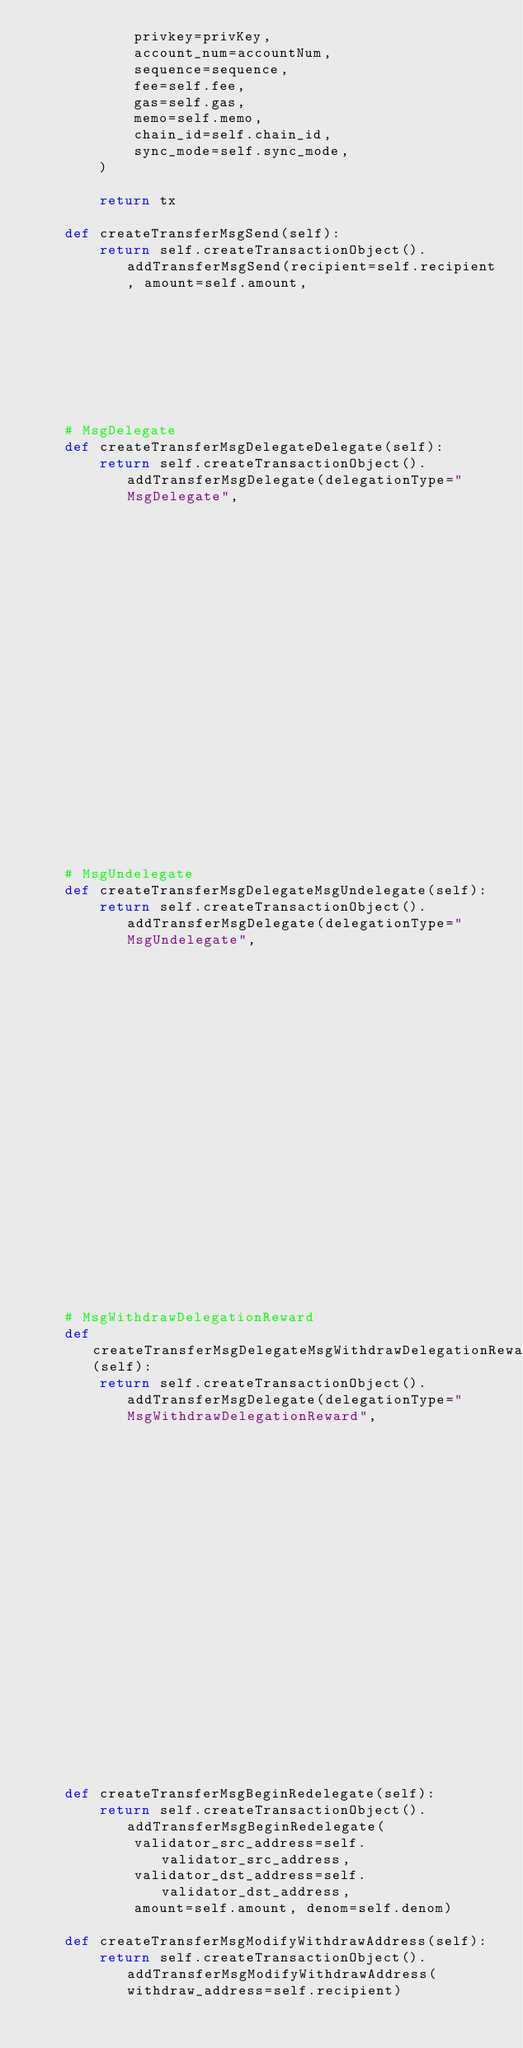<code> <loc_0><loc_0><loc_500><loc_500><_Python_>            privkey=privKey,
            account_num=accountNum,
            sequence=sequence,
            fee=self.fee,
            gas=self.gas,
            memo=self.memo,
            chain_id=self.chain_id,
            sync_mode=self.sync_mode,
        )

        return tx

    def createTransferMsgSend(self):
        return self.createTransactionObject().addTransferMsgSend(recipient=self.recipient, amount=self.amount,
                                                                 denom=self.denom)

    # MsgDelegate
    def createTransferMsgDelegateDelegate(self):
        return self.createTransactionObject().addTransferMsgDelegate(delegationType="MsgDelegate",
                                                                     validator_address=self.validator_address,
                                                                     amount=self.amount, denom=self.denom)

    # MsgUndelegate
    def createTransferMsgDelegateMsgUndelegate(self):
        return self.createTransactionObject().addTransferMsgDelegate(delegationType="MsgUndelegate",
                                                                     validator_address=self.validator_address,
                                                                     amount=self.amount, denom=self.denom)

    # MsgWithdrawDelegationReward
    def createTransferMsgDelegateMsgWithdrawDelegationReward(self):
        return self.createTransactionObject().addTransferMsgDelegate(delegationType="MsgWithdrawDelegationReward",
                                                                     validator_address=self.validator_address,
                                                                     amount=self.amount, denom=self.denom)

    def createTransferMsgBeginRedelegate(self):
        return self.createTransactionObject().addTransferMsgBeginRedelegate(
            validator_src_address=self.validator_src_address,
            validator_dst_address=self.validator_dst_address,
            amount=self.amount, denom=self.denom)

    def createTransferMsgModifyWithdrawAddress(self):
        return self.createTransactionObject().addTransferMsgModifyWithdrawAddress(withdraw_address=self.recipient)



</code> 